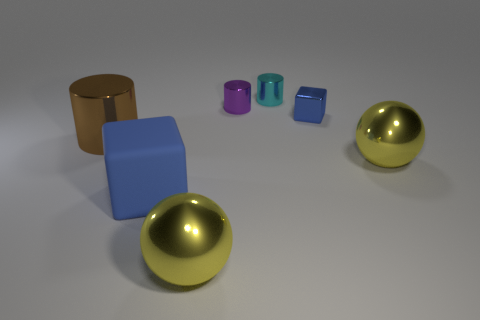Are there any objects in this image that share the same color but differ in shape? Yes, the two golden spheres share the same hue but differ in form from the other objects, which are a mixture of cubes and cylinders. 